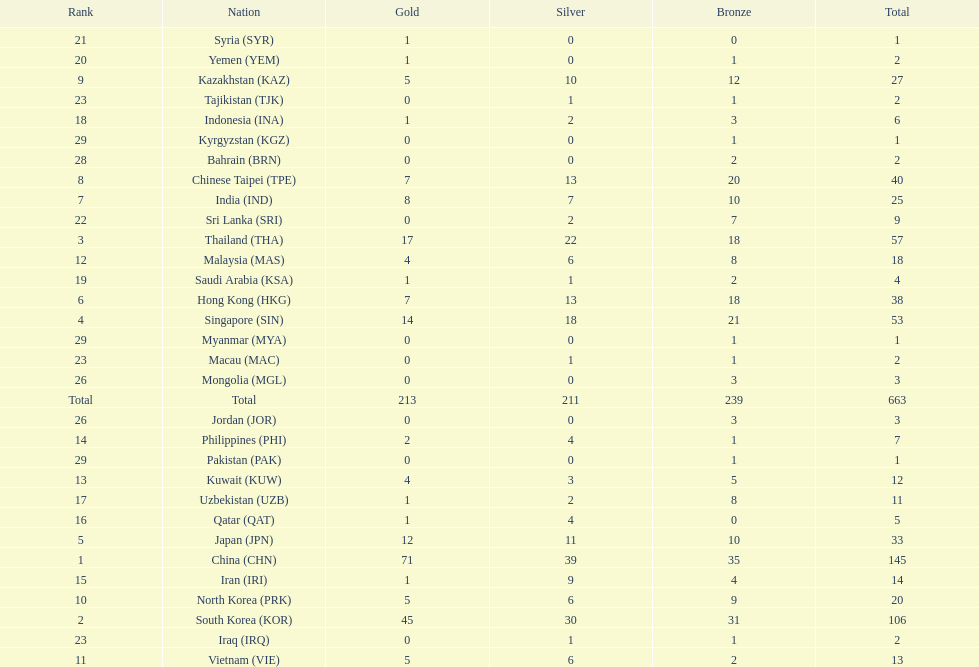What is the total number of medals that india won in the asian youth games? 25. 